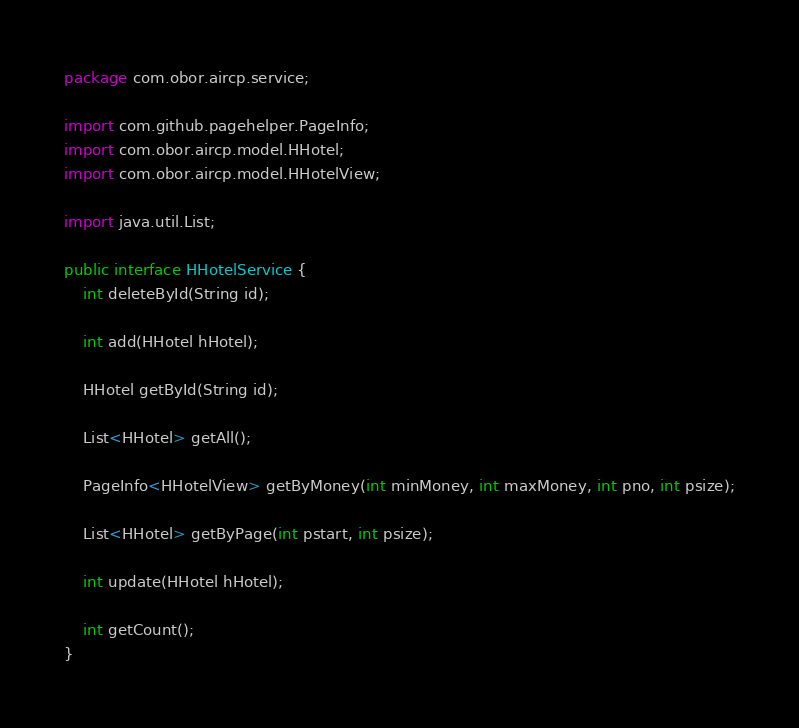<code> <loc_0><loc_0><loc_500><loc_500><_Java_>package com.obor.aircp.service;

import com.github.pagehelper.PageInfo;
import com.obor.aircp.model.HHotel;
import com.obor.aircp.model.HHotelView;

import java.util.List;

public interface HHotelService {
    int deleteById(String id);

    int add(HHotel hHotel);

    HHotel getById(String id);

    List<HHotel> getAll();

    PageInfo<HHotelView> getByMoney(int minMoney, int maxMoney, int pno, int psize);

    List<HHotel> getByPage(int pstart, int psize);

    int update(HHotel hHotel);

    int getCount();
}
</code> 